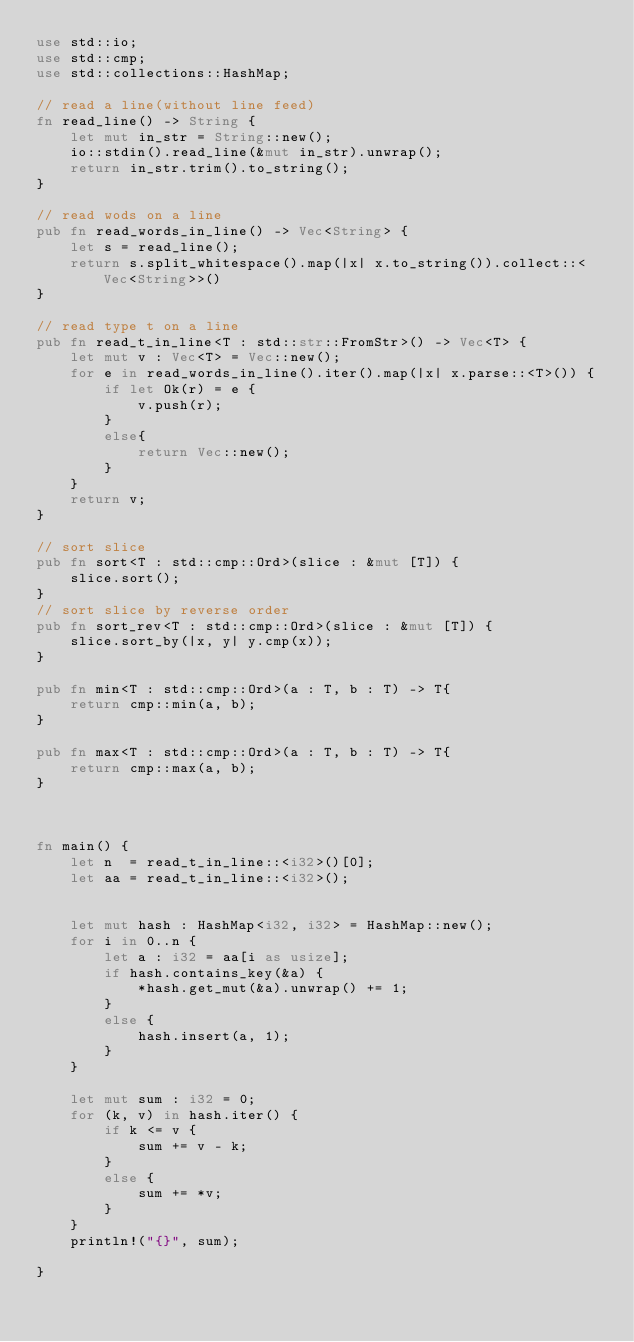<code> <loc_0><loc_0><loc_500><loc_500><_Rust_>use std::io;
use std::cmp;
use std::collections::HashMap;

// read a line(without line feed)
fn read_line() -> String {
    let mut in_str = String::new();
    io::stdin().read_line(&mut in_str).unwrap();
    return in_str.trim().to_string();
}

// read wods on a line
pub fn read_words_in_line() -> Vec<String> {
    let s = read_line();
    return s.split_whitespace().map(|x| x.to_string()).collect::<Vec<String>>()
}

// read type t on a line
pub fn read_t_in_line<T : std::str::FromStr>() -> Vec<T> {
    let mut v : Vec<T> = Vec::new();
    for e in read_words_in_line().iter().map(|x| x.parse::<T>()) {
        if let Ok(r) = e {
            v.push(r);
        }
        else{
            return Vec::new();
        }
    }
    return v;
}

// sort slice
pub fn sort<T : std::cmp::Ord>(slice : &mut [T]) {
    slice.sort();
}
// sort slice by reverse order
pub fn sort_rev<T : std::cmp::Ord>(slice : &mut [T]) {
    slice.sort_by(|x, y| y.cmp(x));
}

pub fn min<T : std::cmp::Ord>(a : T, b : T) -> T{
    return cmp::min(a, b);
}

pub fn max<T : std::cmp::Ord>(a : T, b : T) -> T{
    return cmp::max(a, b);
}



fn main() {
    let n  = read_t_in_line::<i32>()[0];
    let aa = read_t_in_line::<i32>();
    

    let mut hash : HashMap<i32, i32> = HashMap::new();
    for i in 0..n {
        let a : i32 = aa[i as usize];
        if hash.contains_key(&a) {
            *hash.get_mut(&a).unwrap() += 1;
        }
        else {
            hash.insert(a, 1);
        }
    }

    let mut sum : i32 = 0;
    for (k, v) in hash.iter() {
        if k <= v {
            sum += v - k;
        }
        else {
            sum += *v;
        }
    }
    println!("{}", sum);
    
}
</code> 